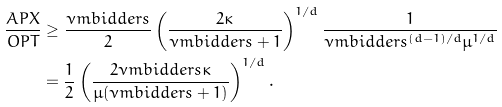<formula> <loc_0><loc_0><loc_500><loc_500>\frac { A P X } { O P T } & \geq \frac { \nu m b i d d e r s } { 2 } \left ( \frac { 2 \kappa } { \nu m b i d d e r s + 1 } \right ) ^ { 1 / d } \frac { 1 } { \nu m b i d d e r s ^ { ( d - 1 ) / d } \mu ^ { 1 / d } } \\ & = \frac { 1 } { 2 } \left ( \frac { 2 \nu m b i d d e r s \kappa } { \mu ( \nu m b i d d e r s + 1 ) } \right ) ^ { 1 / d } .</formula> 